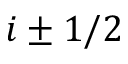Convert formula to latex. <formula><loc_0><loc_0><loc_500><loc_500>i \pm 1 / 2</formula> 